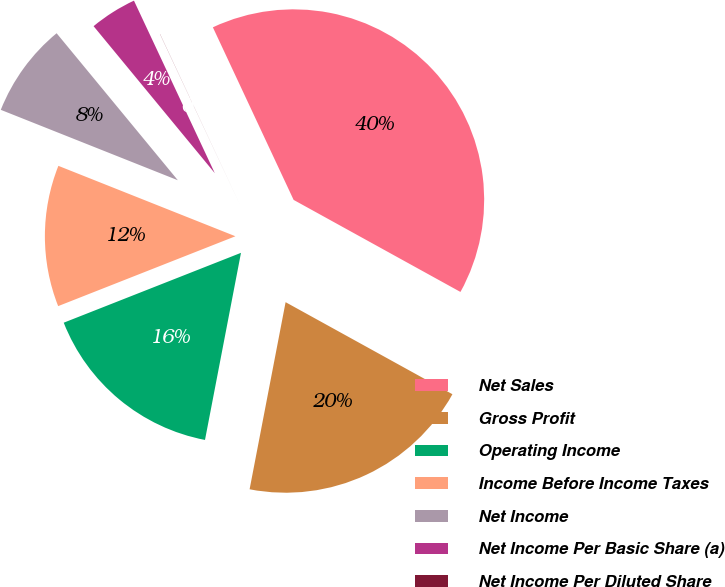Convert chart to OTSL. <chart><loc_0><loc_0><loc_500><loc_500><pie_chart><fcel>Net Sales<fcel>Gross Profit<fcel>Operating Income<fcel>Income Before Income Taxes<fcel>Net Income<fcel>Net Income Per Basic Share (a)<fcel>Net Income Per Diluted Share<nl><fcel>39.99%<fcel>20.0%<fcel>16.0%<fcel>12.0%<fcel>8.0%<fcel>4.0%<fcel>0.01%<nl></chart> 